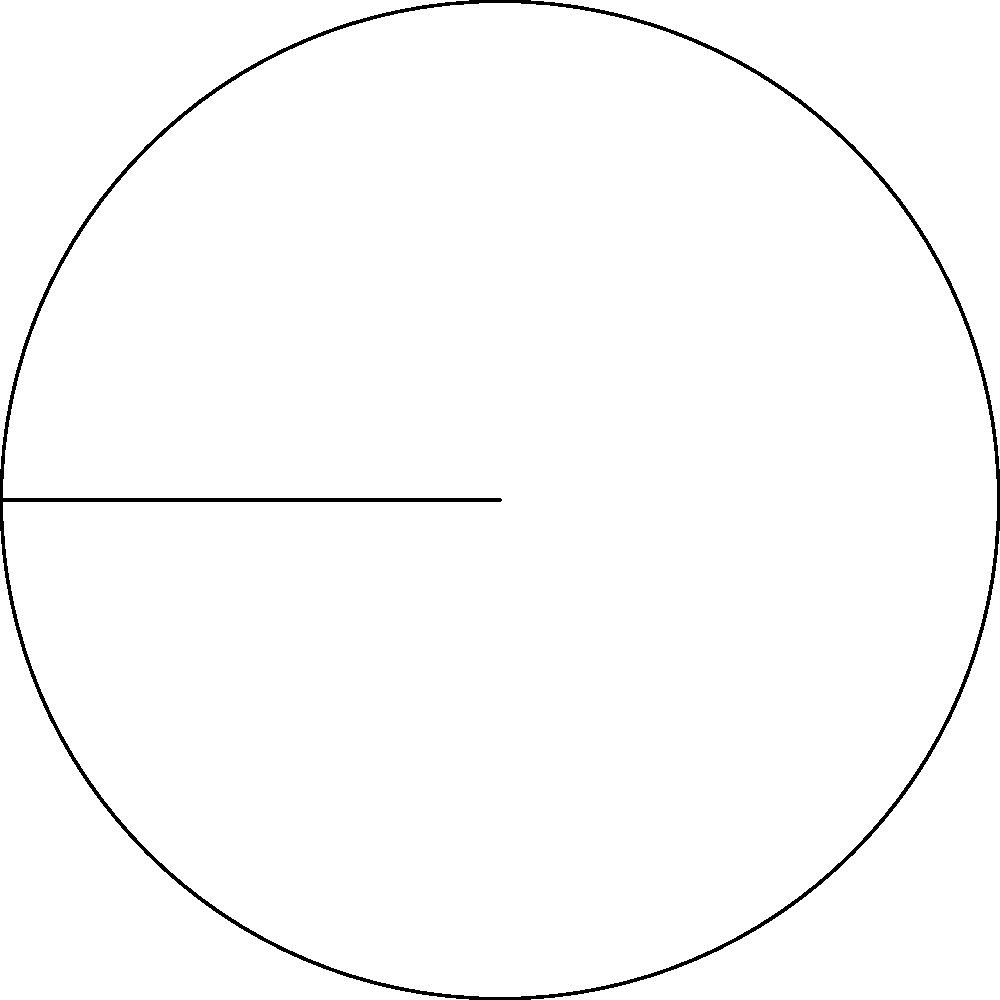As you're preparing a circular examination room for the next patient, you notice that the room's layout resembles a circular sector. The room has a radius of 6 meters, and the sector spans a central angle of 120°. What is the area of this circular sector? To find the area of a circular sector, we can follow these steps:

1) The formula for the area of a circular sector is:

   $$A = \frac{\theta}{360°} \cdot \pi r^2$$

   Where $\theta$ is the central angle in degrees, and $r$ is the radius.

2) We are given:
   $\theta = 120°$
   $r = 6$ meters

3) Let's substitute these values into the formula:

   $$A = \frac{120°}{360°} \cdot \pi \cdot 6^2$$

4) Simplify:
   $$A = \frac{1}{3} \cdot \pi \cdot 36$$

5) Calculate:
   $$A = 12\pi$$

6) If we need a numerical value, we can use $\pi \approx 3.14159$:

   $$A \approx 12 \cdot 3.14159 \approx 37.70$$

Therefore, the area of the circular sector is $12\pi$ square meters, or approximately 37.70 square meters.
Answer: $12\pi$ square meters 